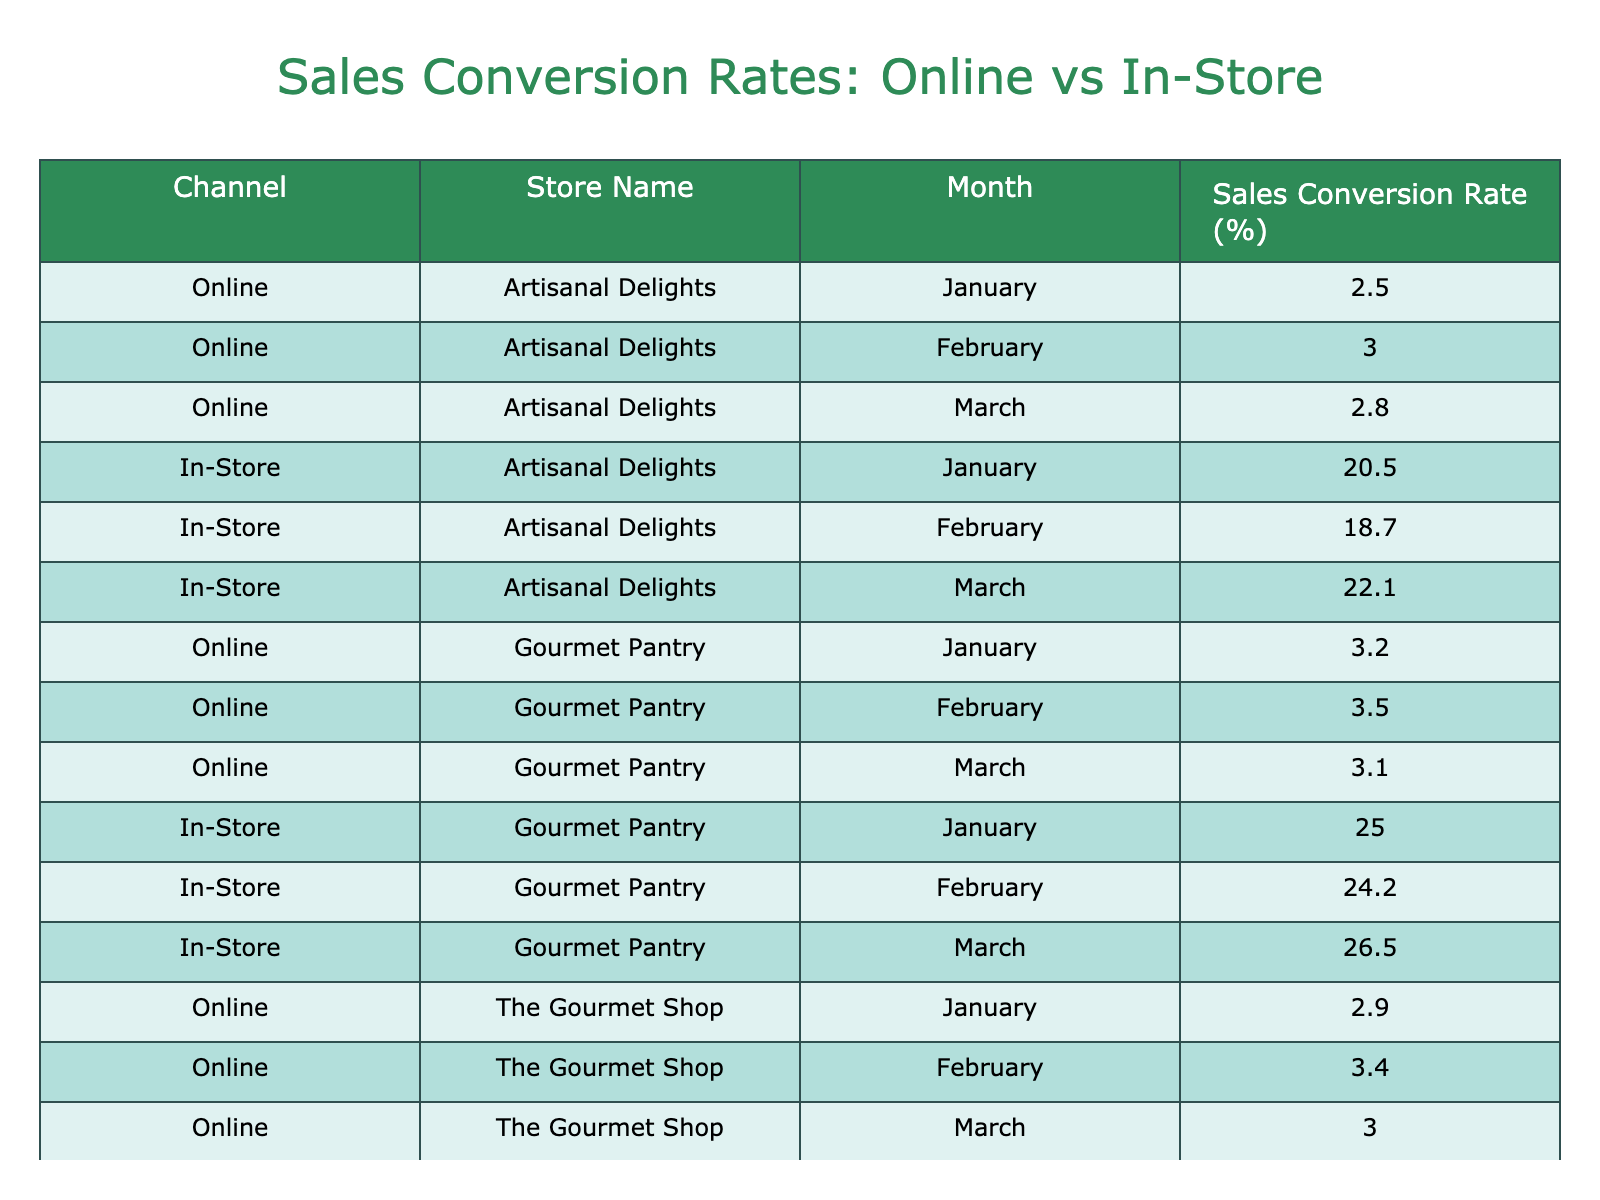What is the sales conversion rate for online purchases in February at Artisanal Delights? The table shows that the sales conversion rate for online purchases at Artisanal Delights in February is 3.0%.
Answer: 3.0% Which store had the highest in-store sales conversion rate in March? In March, Gourmet Pantry had the highest in-store sales conversion rate of 26.5%.
Answer: 26.5% What is the difference in sales conversion rates between in-store and online purchases for Artisanal Delights in January? For Artisanal Delights in January, the in-store sales conversion rate is 20.5% and the online rate is 2.5%. The difference is 20.5% - 2.5% = 18.0%.
Answer: 18.0% Is the online sales conversion rate for The Gourmet Shop higher in January or February? In January, the online sales conversion rate for The Gourmet Shop is 2.9%, while in February it is 3.4%. Therefore, February has the higher rate.
Answer: Yes What is the average sales conversion rate for online purchases across all stores for March? For March, calculating the average of the online rates: (2.8 + 3.1 + 3.0) / 3 = 2.9667, rounded to 3.0%.
Answer: 3.0% How much lower was the in-store sales conversion rate in February for Artisanal Delights compared to Gourmet Pantry? In February, the in-store sales conversion rate for Artisanal Delights is 18.7% and for Gourmet Pantry is 24.2%. The difference is 24.2% - 18.7% = 5.5%.
Answer: 5.5% Did any store have a consistent sales conversion rate for online purchases for all three months? Evaluating the online rates for each store: Artisanal Delights varied (2.5, 3.0, 2.8), Gourmet Pantry varied (3.2, 3.5, 3.1), and The Gourmet Shop varied (2.9, 3.4, 3.0). None of the stores had consistent rates.
Answer: No What is the overall trend in in-store sales conversion rates from January to March for all stores? Looking at the in-store sales conversion rates, they show an upward trend: Artisanal Delights (20.5, 18.7, 22.1), Gourmet Pantry (25.0, 24.2, 26.5), The Gourmet Shop (21.3, 19.9, 20.5). Hence, the overall trend is upward for Gourmet Pantry and fluctuating for the others.
Answer: Mixed trend 